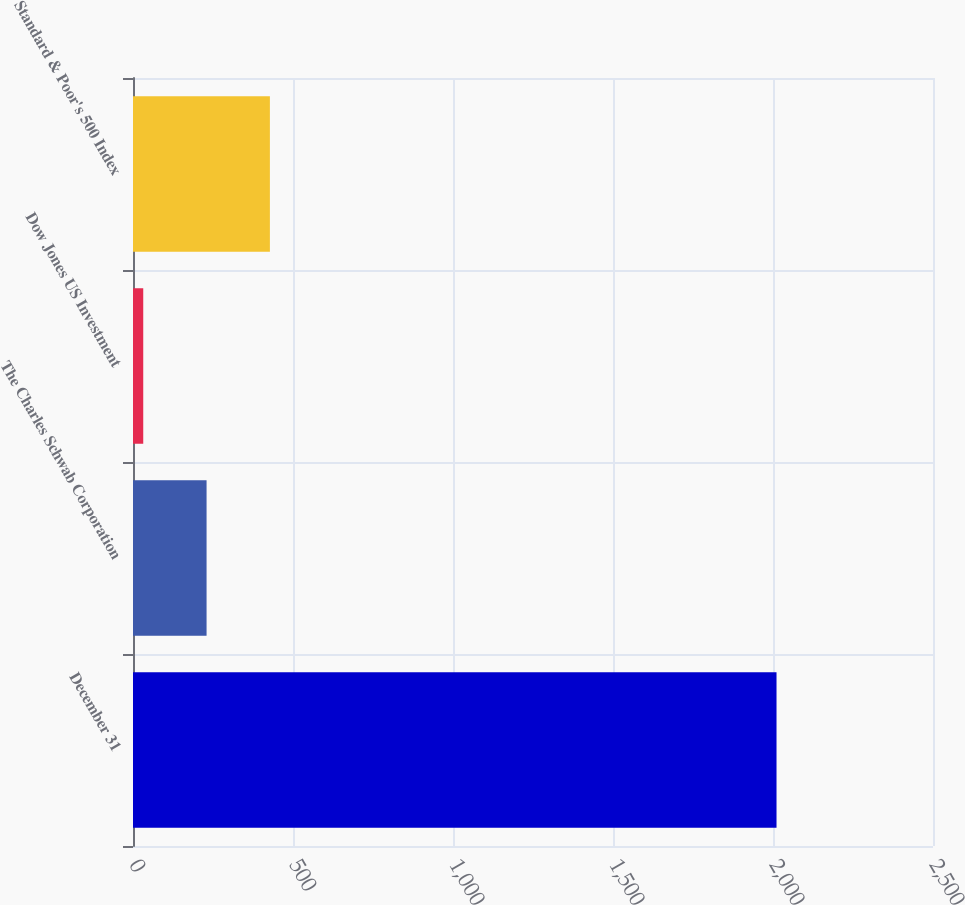Convert chart to OTSL. <chart><loc_0><loc_0><loc_500><loc_500><bar_chart><fcel>December 31<fcel>The Charles Schwab Corporation<fcel>Dow Jones US Investment<fcel>Standard & Poor's 500 Index<nl><fcel>2011<fcel>229.9<fcel>32<fcel>427.8<nl></chart> 